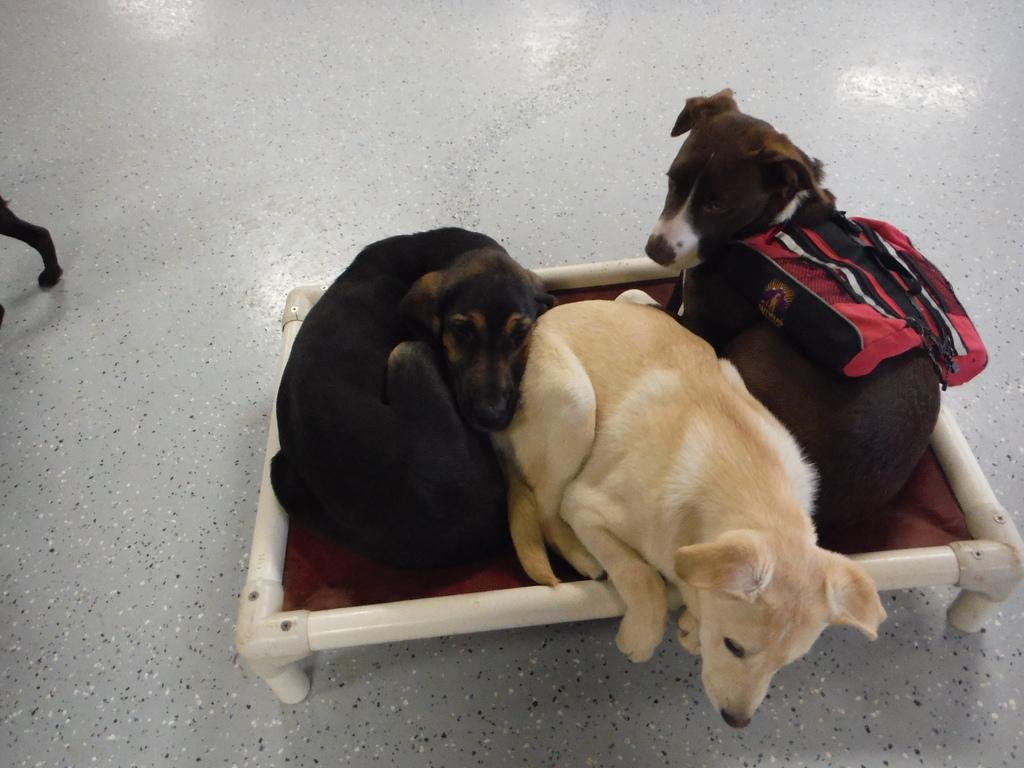How many dogs are present in the image? There are three dogs in the image. Where are the dogs located? The dogs are on a table in the image. What is the table resting on? The table is placed on the ground. What type of creature is holding the cart in the image? There is no creature or cart present in the image. How many sticks are being carried by the dogs in the image? There are no sticks present in the image. 